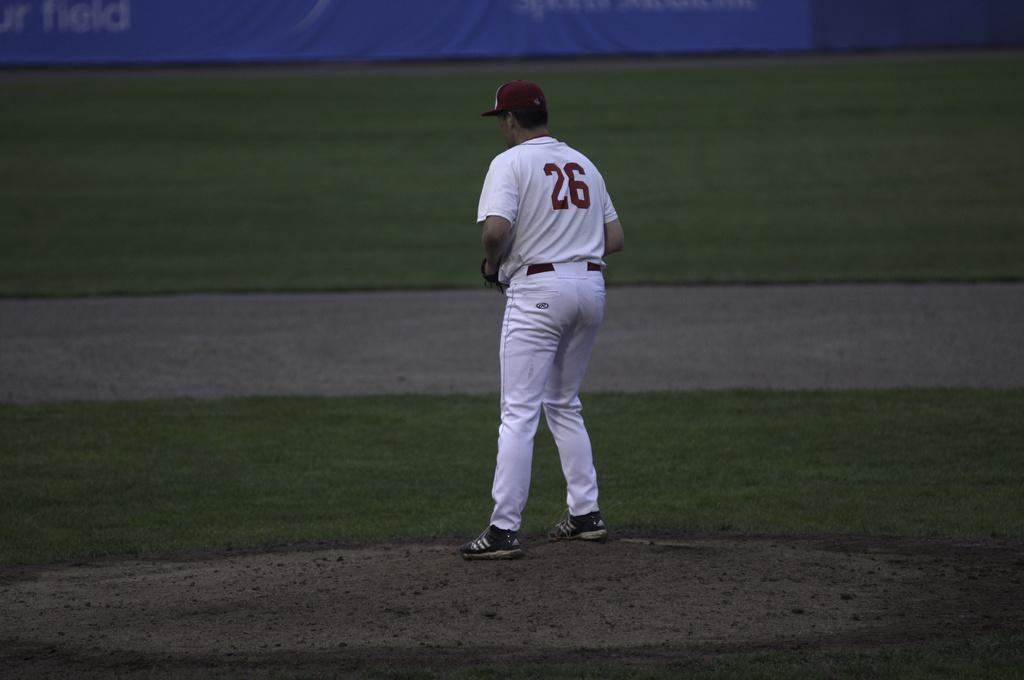<image>
Write a terse but informative summary of the picture. Baseball player number 26 stands on the pitcher's mound. 